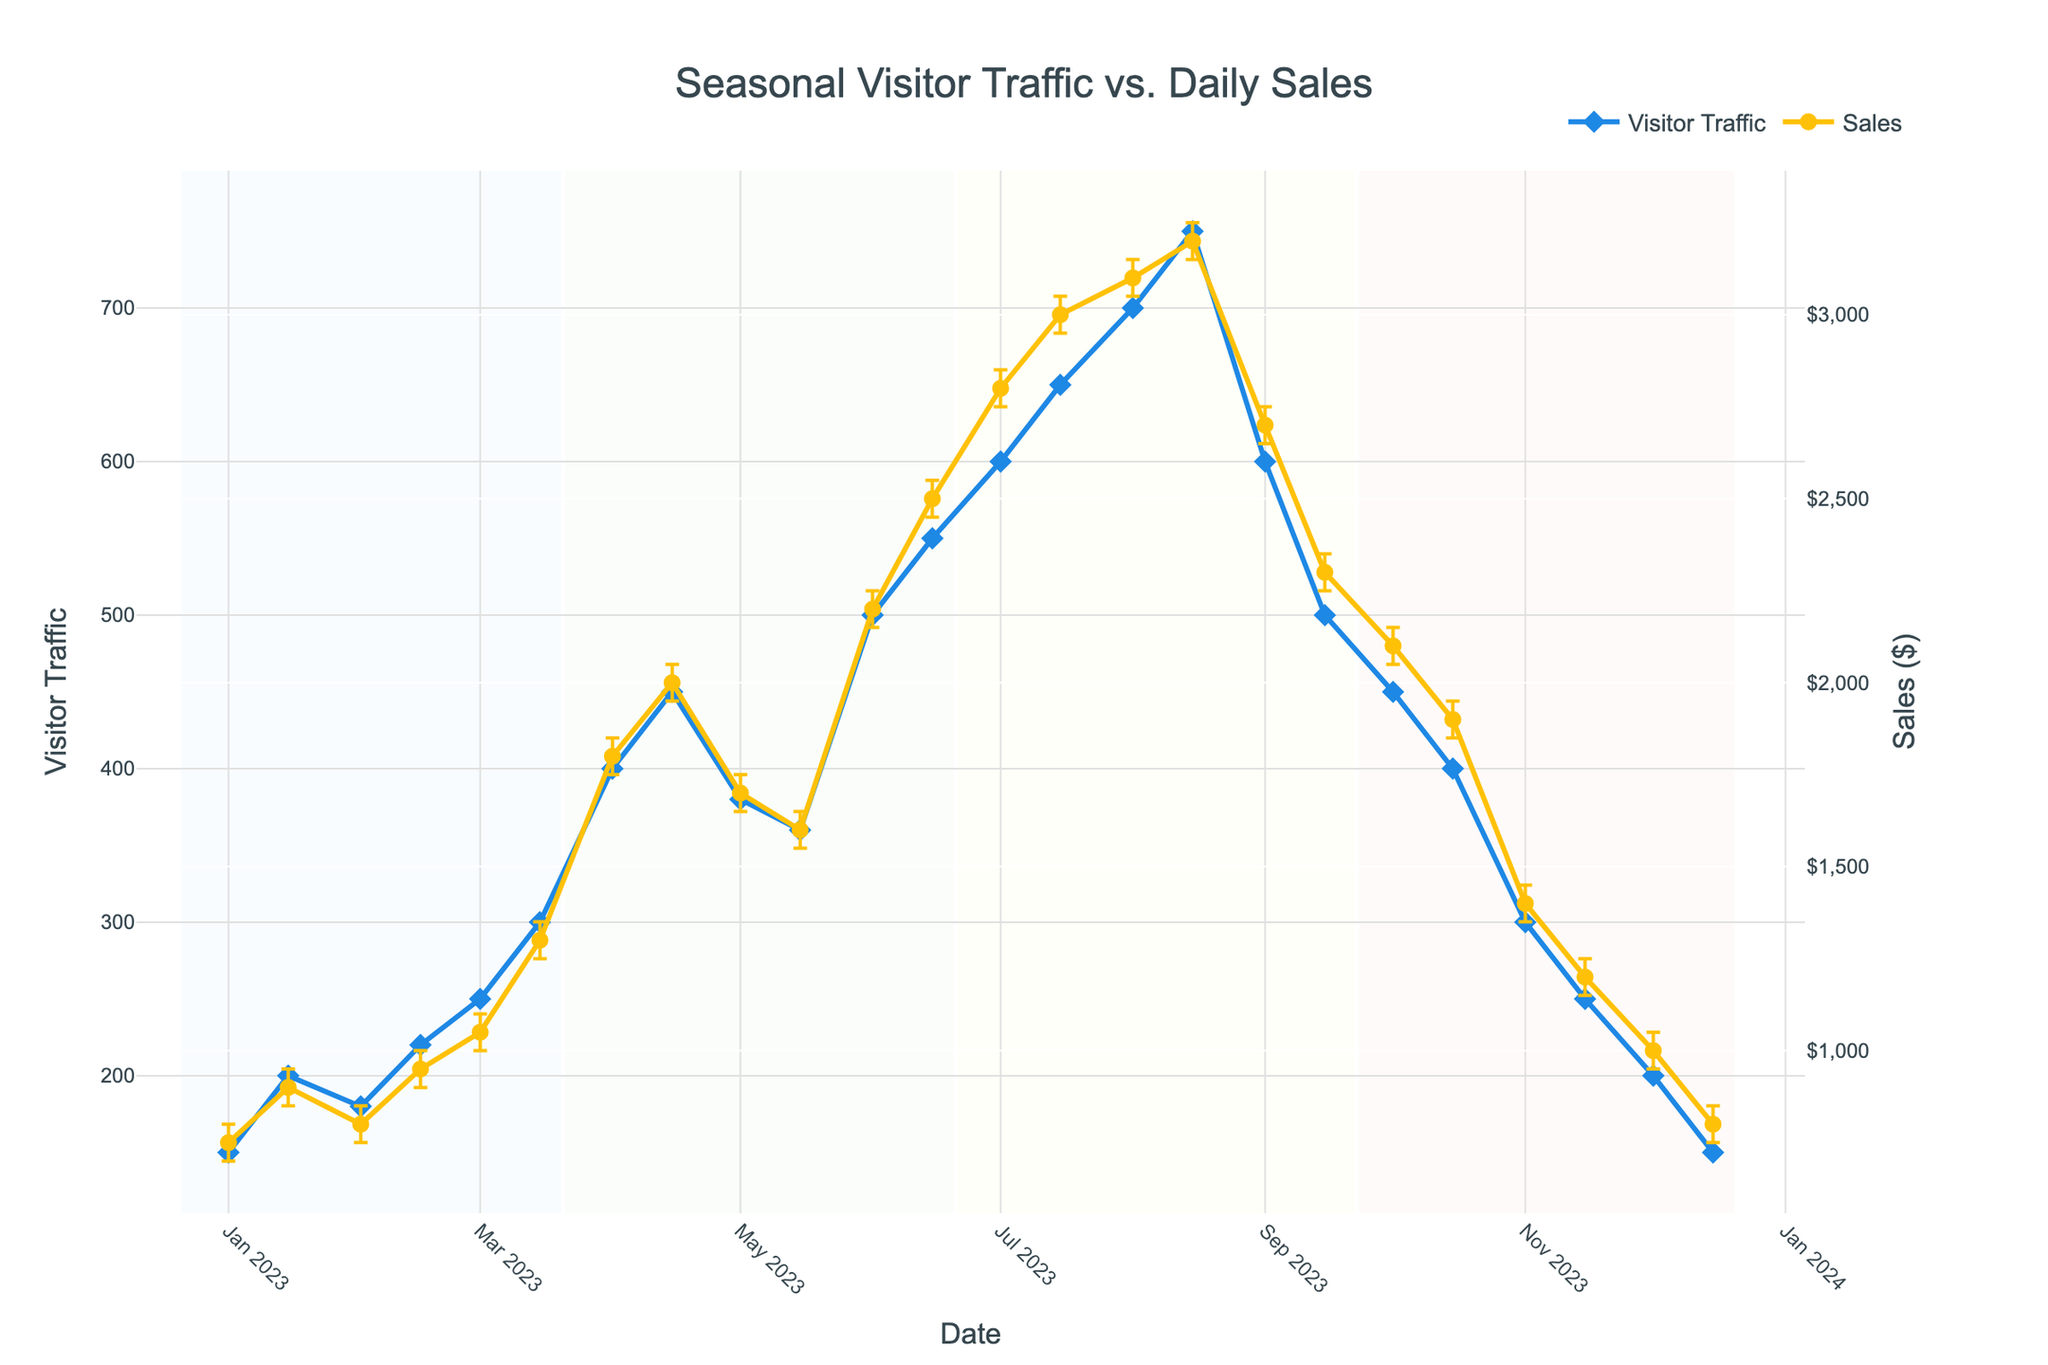How does visitor traffic correlate with daily sales during summer? To determine this, look at the visitor traffic and sales data points between late June and late September, marked by the light yellow background. It visually appears that as visitor traffic increases, the daily sales also increase significantly with the visitor numbers ranging from 500 to 750 and corresponding sales moving from $2200 to $3200.
Answer: Both increase significantly What is the sales range given by the confidence interval for April 15? To find this, look at the date April 15 on the x-axis and find its corresponding point on the sales y-axis. The confidence interval range is shown by the error bars spanning from $1950 to $2050.
Answer: $1950 to $2050 On which date was the highest visitor traffic recorded? Check the scatter plot for the highest point on the Visitor Traffic y-axis and then trace it back to the corresponding date on the x-axis. The highest traffic of 750 visitors was recorded on August 15.
Answer: August 15 During which season did the sales peak, and what was the peak value? Identify the season by the background color of the plot. The highest sales point occurs on August 15 with a value of $3200, which falls under the summer season (light yellow background).
Answer: Summer, $3200 Compare visitor traffic and sales on March 1 and November 15. Which date had higher values and by how much? For March 1, visitor traffic is 250 and sales are $1050. For November 15, visitor traffic is 250, and sales are $1200. Both dates have the same visitor traffic, but November 15 has higher sales by $150 ($1200 - $1050).
Answer: November 15, sales higher by $150 What is the trend in sales from January to December? Observe the line for sales starting from January to December. Sales show an overall increasing trend from January ($750) to a peak in August ($3200), followed by a decreasing trend towards December ($800).
Answer: Increased, then decreased How accurately can we predict sales for May 1? Check the error bars around the sales point for May 1. The error bars indicate that sales can vary between $1650 and $1750, suggesting relatively low uncertainty and a concentrated prediction range.
Answer: Between $1650 and $1750 Between which months does the visitor traffic show the largest increase? Look for the steepest slope in the visitor traffic line. The largest increase in visitor traffic happens between March 15 and June 15, where it increases from 300 to 550 (a difference of 250).
Answer: March 15 to June 15 Which date has the largest sales confidence interval, and what is its range? Identify the date with the longest error bar. The date is August 1 with sales ranging from $3050 to $3150, making the confidence interval range $100 ($3150 - $3050).
Answer: August 1, $100 